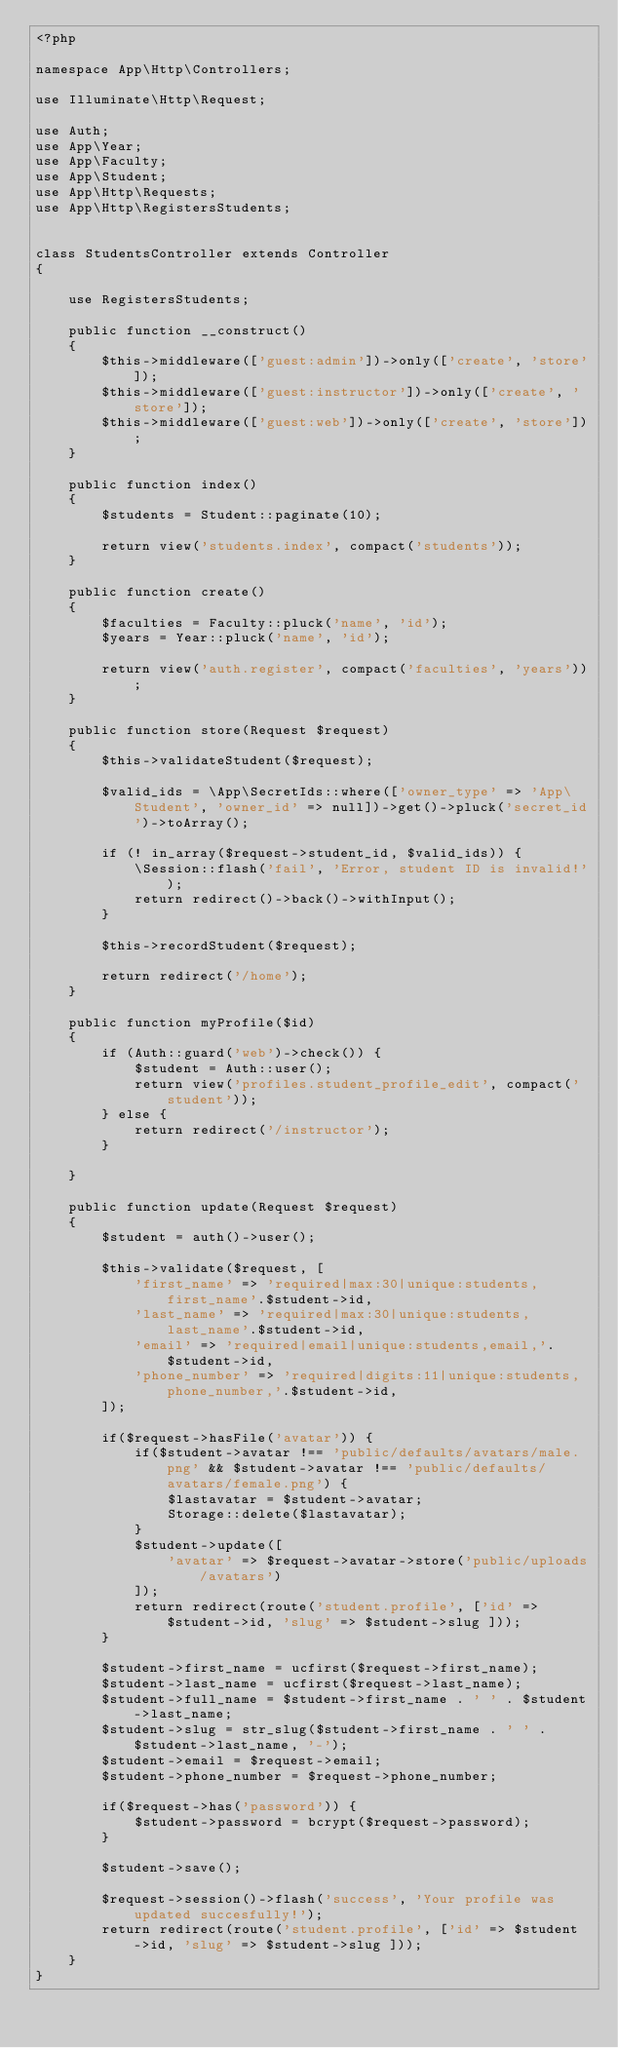<code> <loc_0><loc_0><loc_500><loc_500><_PHP_><?php

namespace App\Http\Controllers;

use Illuminate\Http\Request;

use Auth;
use App\Year;
use App\Faculty;
use App\Student;
use App\Http\Requests;
use App\Http\RegistersStudents;


class StudentsController extends Controller
{

    use RegistersStudents;

    public function __construct()
    {
        $this->middleware(['guest:admin'])->only(['create', 'store']);
        $this->middleware(['guest:instructor'])->only(['create', 'store']);
        $this->middleware(['guest:web'])->only(['create', 'store']);
    }

    public function index()
    {
        $students = Student::paginate(10);

        return view('students.index', compact('students'));
    }

    public function create()
    {
        $faculties = Faculty::pluck('name', 'id');
        $years = Year::pluck('name', 'id');

        return view('auth.register', compact('faculties', 'years'));
    }

    public function store(Request $request)
    {
        $this->validateStudent($request);

        $valid_ids = \App\SecretIds::where(['owner_type' => 'App\Student', 'owner_id' => null])->get()->pluck('secret_id')->toArray();

        if (! in_array($request->student_id, $valid_ids)) {
            \Session::flash('fail', 'Error, student ID is invalid!');
            return redirect()->back()->withInput();
        }

        $this->recordStudent($request);

        return redirect('/home');
    }

    public function myProfile($id)
    {
        if (Auth::guard('web')->check()) {
            $student = Auth::user();
            return view('profiles.student_profile_edit', compact('student'));
        } else {
            return redirect('/instructor');
        }
        
    }

    public function update(Request $request)
    {
        $student = auth()->user();

        $this->validate($request, [
            'first_name' => 'required|max:30|unique:students,first_name'.$student->id,
            'last_name' => 'required|max:30|unique:students,last_name'.$student->id,
            'email' => 'required|email|unique:students,email,'.$student->id,
            'phone_number' => 'required|digits:11|unique:students,phone_number,'.$student->id,
        ]);

        if($request->hasFile('avatar')) {
            if($student->avatar !== 'public/defaults/avatars/male.png' && $student->avatar !== 'public/defaults/avatars/female.png') {
                $lastavatar = $student->avatar;
                Storage::delete($lastavatar);
            }
            $student->update([
                'avatar' => $request->avatar->store('public/uploads/avatars')
            ]);
            return redirect(route('student.profile', ['id' => $student->id, 'slug' => $student->slug ]));
        }

        $student->first_name = ucfirst($request->first_name);
        $student->last_name = ucfirst($request->last_name);
        $student->full_name = $student->first_name . ' ' . $student->last_name;
        $student->slug = str_slug($student->first_name . ' ' . $student->last_name, '-');
        $student->email = $request->email;
        $student->phone_number = $request->phone_number;

        if($request->has('password')) {
            $student->password = bcrypt($request->password);
        }

        $student->save();

        $request->session()->flash('success', 'Your profile was updated succesfully!');
        return redirect(route('student.profile', ['id' => $student->id, 'slug' => $student->slug ]));
    }
}
</code> 